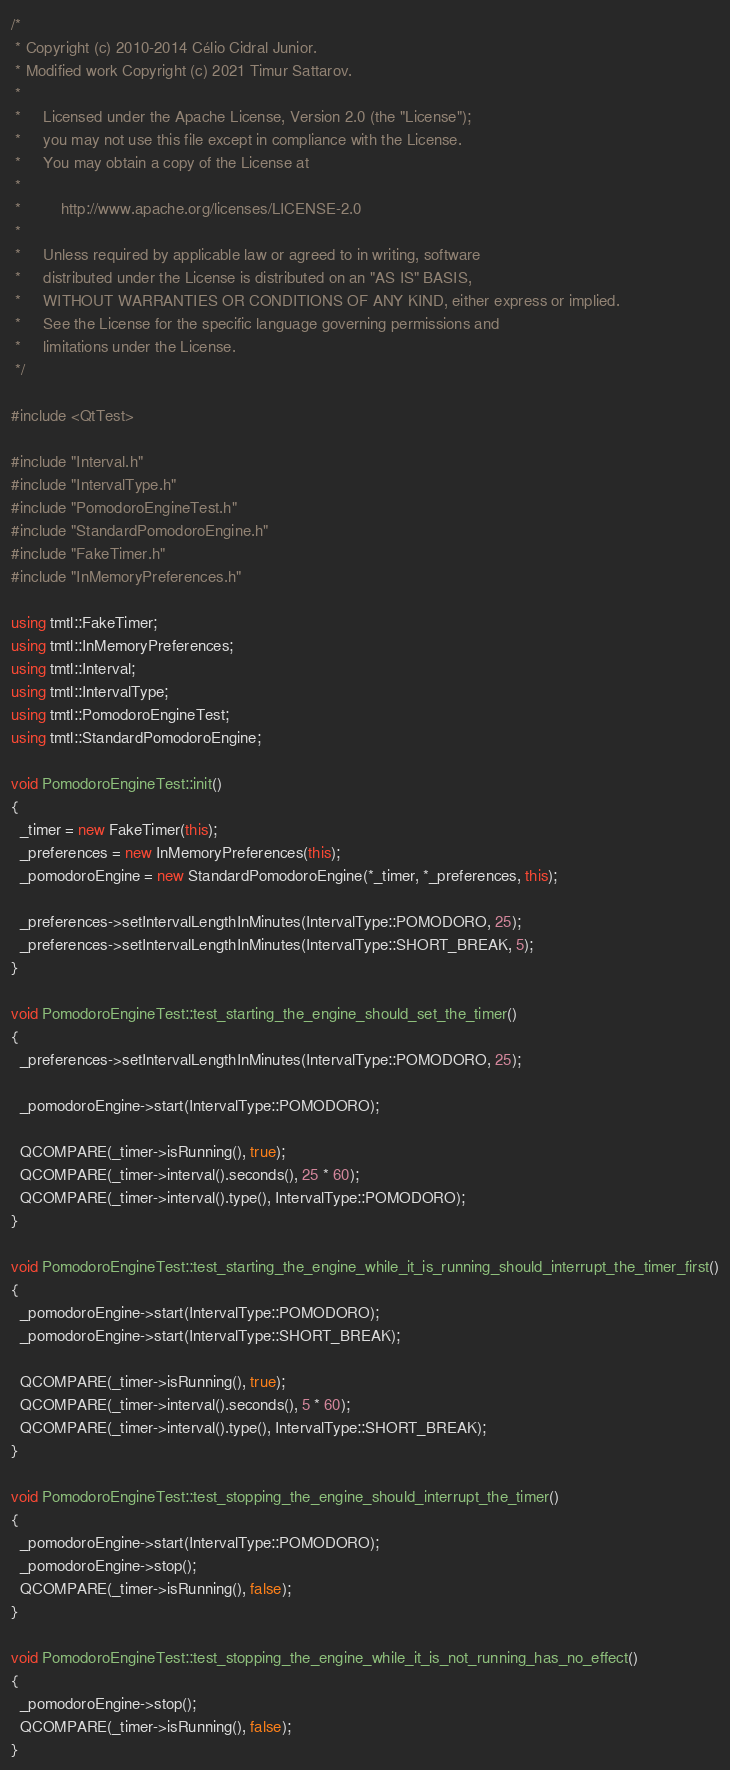<code> <loc_0><loc_0><loc_500><loc_500><_C++_>/*
 * Copyright (c) 2010-2014 Célio Cidral Junior.
 * Modified work Copyright (c) 2021 Timur Sattarov.
 *
 *     Licensed under the Apache License, Version 2.0 (the "License");
 *     you may not use this file except in compliance with the License.
 *     You may obtain a copy of the License at
 *
 *         http://www.apache.org/licenses/LICENSE-2.0
 *
 *     Unless required by applicable law or agreed to in writing, software
 *     distributed under the License is distributed on an "AS IS" BASIS,
 *     WITHOUT WARRANTIES OR CONDITIONS OF ANY KIND, either express or implied.
 *     See the License for the specific language governing permissions and
 *     limitations under the License.
 */

#include <QtTest>

#include "Interval.h"
#include "IntervalType.h"
#include "PomodoroEngineTest.h"
#include "StandardPomodoroEngine.h"
#include "FakeTimer.h"
#include "InMemoryPreferences.h"

using tmtl::FakeTimer;
using tmtl::InMemoryPreferences;
using tmtl::Interval;
using tmtl::IntervalType;
using tmtl::PomodoroEngineTest;
using tmtl::StandardPomodoroEngine;

void PomodoroEngineTest::init()
{
  _timer = new FakeTimer(this);
  _preferences = new InMemoryPreferences(this);
  _pomodoroEngine = new StandardPomodoroEngine(*_timer, *_preferences, this);

  _preferences->setIntervalLengthInMinutes(IntervalType::POMODORO, 25);
  _preferences->setIntervalLengthInMinutes(IntervalType::SHORT_BREAK, 5);
}

void PomodoroEngineTest::test_starting_the_engine_should_set_the_timer()
{
  _preferences->setIntervalLengthInMinutes(IntervalType::POMODORO, 25);

  _pomodoroEngine->start(IntervalType::POMODORO);

  QCOMPARE(_timer->isRunning(), true);
  QCOMPARE(_timer->interval().seconds(), 25 * 60);
  QCOMPARE(_timer->interval().type(), IntervalType::POMODORO);
}

void PomodoroEngineTest::test_starting_the_engine_while_it_is_running_should_interrupt_the_timer_first()
{
  _pomodoroEngine->start(IntervalType::POMODORO);
  _pomodoroEngine->start(IntervalType::SHORT_BREAK);

  QCOMPARE(_timer->isRunning(), true);
  QCOMPARE(_timer->interval().seconds(), 5 * 60);
  QCOMPARE(_timer->interval().type(), IntervalType::SHORT_BREAK);
}

void PomodoroEngineTest::test_stopping_the_engine_should_interrupt_the_timer()
{
  _pomodoroEngine->start(IntervalType::POMODORO);
  _pomodoroEngine->stop();
  QCOMPARE(_timer->isRunning(), false);
}

void PomodoroEngineTest::test_stopping_the_engine_while_it_is_not_running_has_no_effect()
{
  _pomodoroEngine->stop();
  QCOMPARE(_timer->isRunning(), false);
}
</code> 